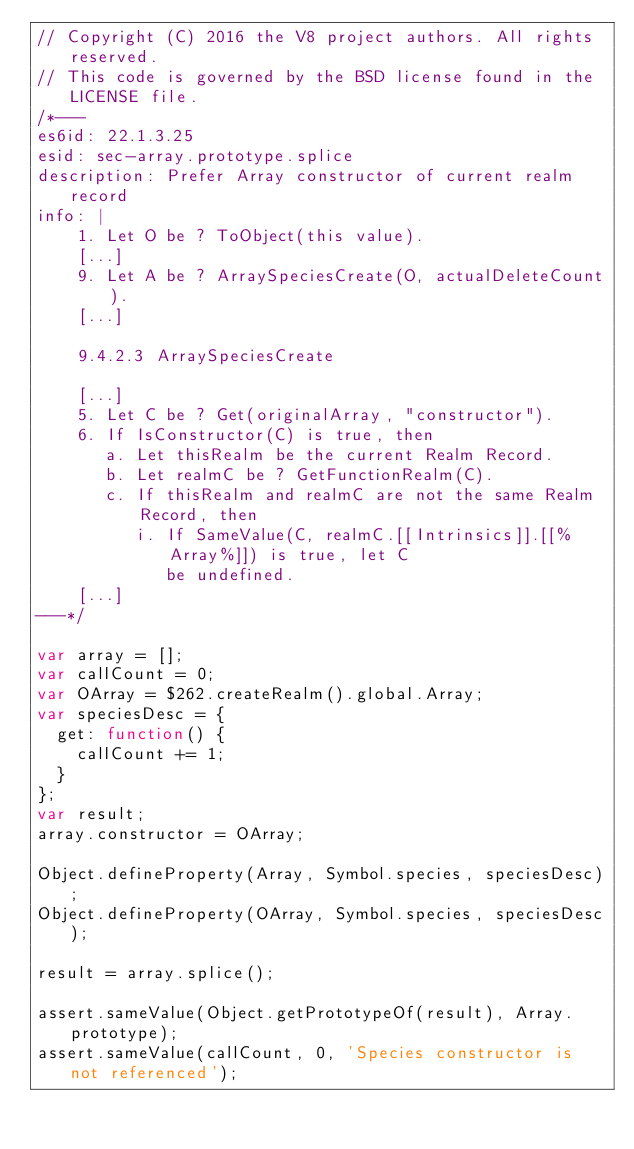<code> <loc_0><loc_0><loc_500><loc_500><_JavaScript_>// Copyright (C) 2016 the V8 project authors. All rights reserved.
// This code is governed by the BSD license found in the LICENSE file.
/*---
es6id: 22.1.3.25
esid: sec-array.prototype.splice
description: Prefer Array constructor of current realm record
info: |
    1. Let O be ? ToObject(this value).
    [...]
    9. Let A be ? ArraySpeciesCreate(O, actualDeleteCount).
    [...]

    9.4.2.3 ArraySpeciesCreate

    [...]
    5. Let C be ? Get(originalArray, "constructor").
    6. If IsConstructor(C) is true, then
       a. Let thisRealm be the current Realm Record.
       b. Let realmC be ? GetFunctionRealm(C).
       c. If thisRealm and realmC are not the same Realm Record, then
          i. If SameValue(C, realmC.[[Intrinsics]].[[%Array%]]) is true, let C
             be undefined.
    [...]
---*/

var array = [];
var callCount = 0;
var OArray = $262.createRealm().global.Array;
var speciesDesc = {
  get: function() {
    callCount += 1;
  }
};
var result;
array.constructor = OArray;

Object.defineProperty(Array, Symbol.species, speciesDesc);
Object.defineProperty(OArray, Symbol.species, speciesDesc);

result = array.splice();

assert.sameValue(Object.getPrototypeOf(result), Array.prototype);
assert.sameValue(callCount, 0, 'Species constructor is not referenced');
</code> 